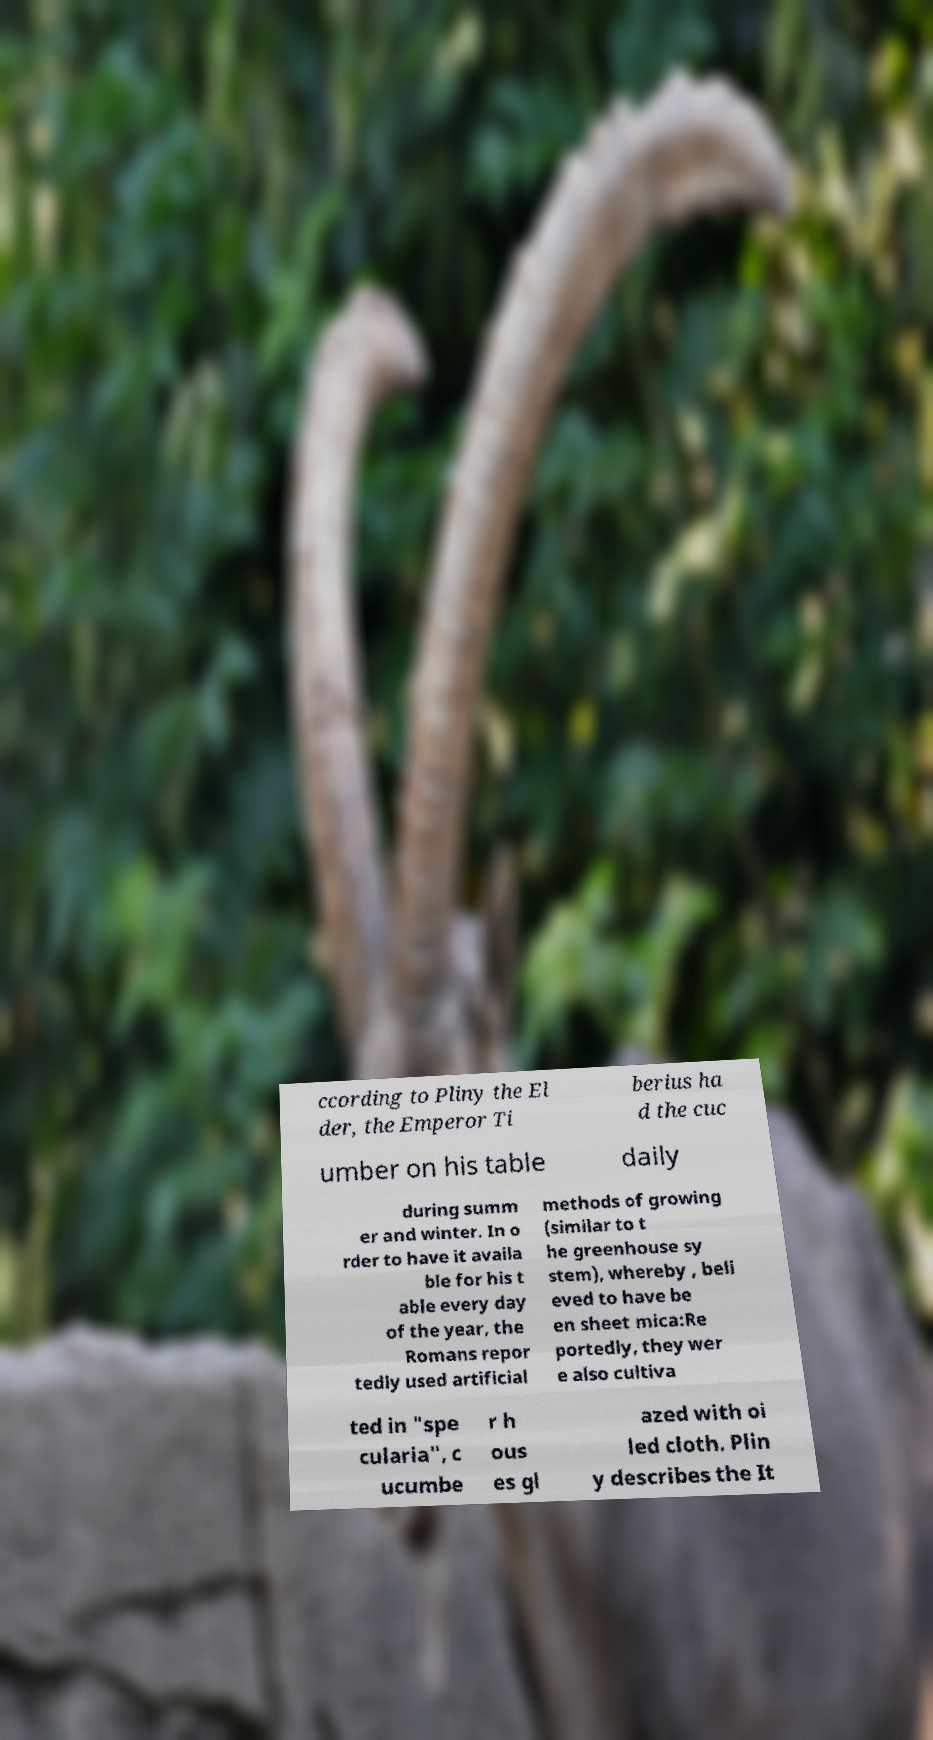I need the written content from this picture converted into text. Can you do that? ccording to Pliny the El der, the Emperor Ti berius ha d the cuc umber on his table daily during summ er and winter. In o rder to have it availa ble for his t able every day of the year, the Romans repor tedly used artificial methods of growing (similar to t he greenhouse sy stem), whereby , beli eved to have be en sheet mica:Re portedly, they wer e also cultiva ted in "spe cularia", c ucumbe r h ous es gl azed with oi led cloth. Plin y describes the It 